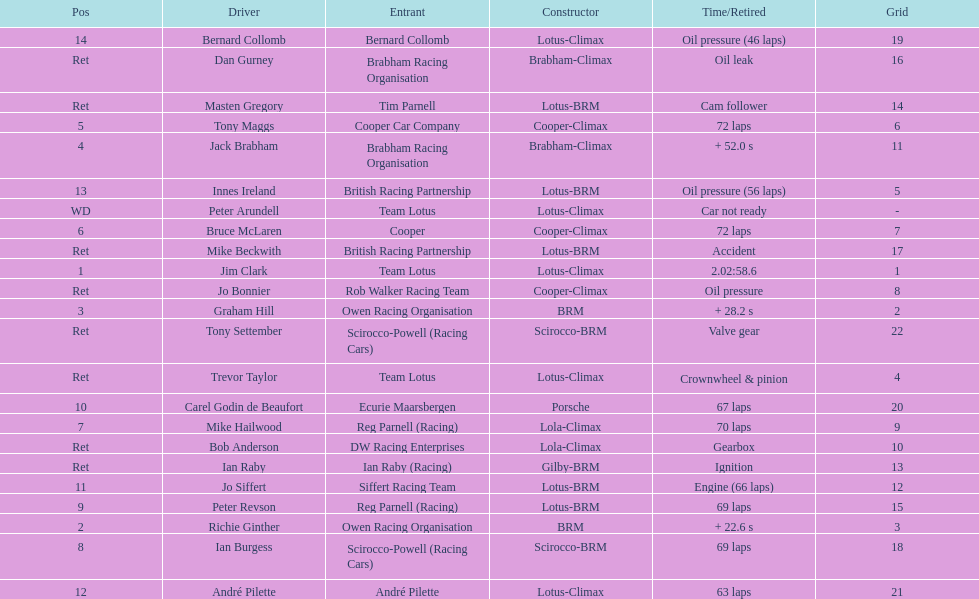Who came in earlier, tony maggs or jo siffert? Tony Maggs. 